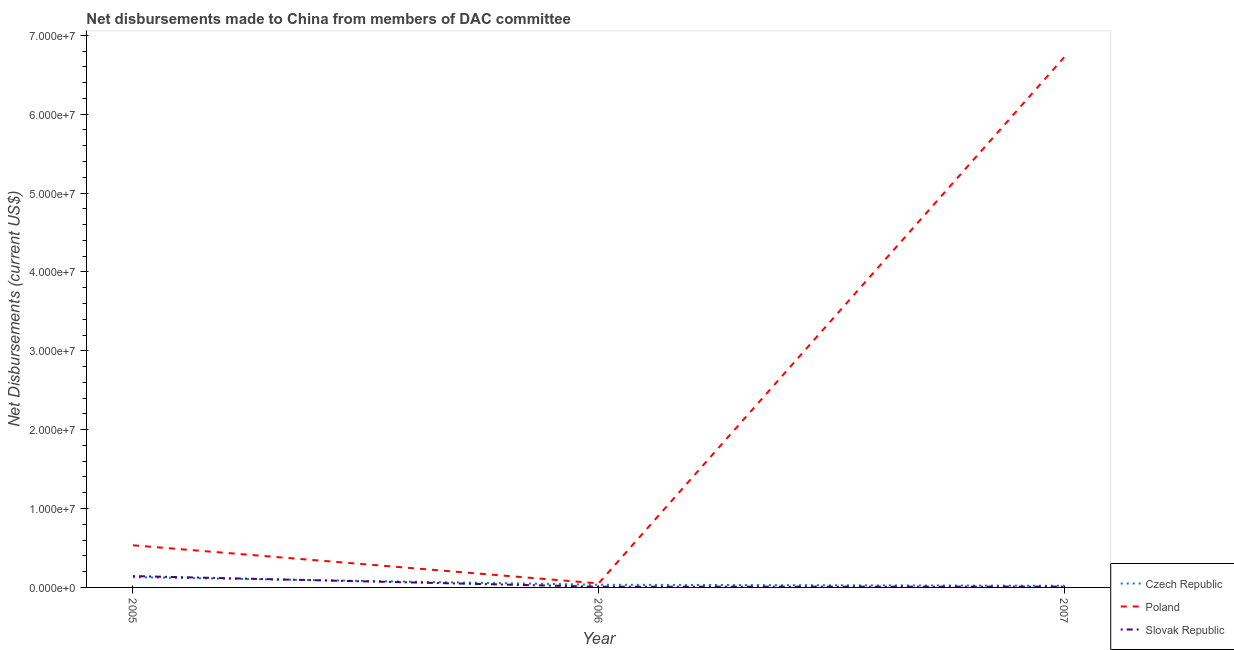How many different coloured lines are there?
Ensure brevity in your answer.  3. What is the net disbursements made by slovak republic in 2007?
Your answer should be very brief. 1.00e+05. Across all years, what is the maximum net disbursements made by poland?
Your answer should be compact. 6.72e+07. Across all years, what is the minimum net disbursements made by poland?
Keep it short and to the point. 5.10e+05. In which year was the net disbursements made by poland minimum?
Give a very brief answer. 2006. What is the total net disbursements made by czech republic in the graph?
Your response must be concise. 1.85e+06. What is the difference between the net disbursements made by slovak republic in 2005 and that in 2007?
Provide a short and direct response. 1.34e+06. What is the difference between the net disbursements made by poland in 2007 and the net disbursements made by czech republic in 2005?
Your answer should be very brief. 6.59e+07. What is the average net disbursements made by poland per year?
Provide a succinct answer. 2.44e+07. In the year 2005, what is the difference between the net disbursements made by slovak republic and net disbursements made by poland?
Provide a succinct answer. -3.90e+06. In how many years, is the net disbursements made by czech republic greater than 32000000 US$?
Your answer should be compact. 0. What is the ratio of the net disbursements made by czech republic in 2005 to that in 2007?
Offer a very short reply. 6.19. Is the net disbursements made by czech republic in 2006 less than that in 2007?
Your answer should be very brief. No. Is the difference between the net disbursements made by poland in 2005 and 2006 greater than the difference between the net disbursements made by czech republic in 2005 and 2006?
Provide a succinct answer. Yes. What is the difference between the highest and the second highest net disbursements made by czech republic?
Ensure brevity in your answer.  9.60e+05. What is the difference between the highest and the lowest net disbursements made by poland?
Keep it short and to the point. 6.67e+07. In how many years, is the net disbursements made by poland greater than the average net disbursements made by poland taken over all years?
Give a very brief answer. 1. Is it the case that in every year, the sum of the net disbursements made by czech republic and net disbursements made by poland is greater than the net disbursements made by slovak republic?
Offer a terse response. Yes. Does the net disbursements made by poland monotonically increase over the years?
Make the answer very short. No. What is the difference between two consecutive major ticks on the Y-axis?
Offer a very short reply. 1.00e+07. Are the values on the major ticks of Y-axis written in scientific E-notation?
Your response must be concise. Yes. Where does the legend appear in the graph?
Make the answer very short. Bottom right. How many legend labels are there?
Your response must be concise. 3. What is the title of the graph?
Keep it short and to the point. Net disbursements made to China from members of DAC committee. What is the label or title of the X-axis?
Make the answer very short. Year. What is the label or title of the Y-axis?
Make the answer very short. Net Disbursements (current US$). What is the Net Disbursements (current US$) in Czech Republic in 2005?
Provide a short and direct response. 1.30e+06. What is the Net Disbursements (current US$) in Poland in 2005?
Give a very brief answer. 5.34e+06. What is the Net Disbursements (current US$) of Slovak Republic in 2005?
Make the answer very short. 1.44e+06. What is the Net Disbursements (current US$) of Poland in 2006?
Offer a terse response. 5.10e+05. What is the Net Disbursements (current US$) in Slovak Republic in 2006?
Offer a terse response. 9.00e+04. What is the Net Disbursements (current US$) in Poland in 2007?
Offer a terse response. 6.72e+07. Across all years, what is the maximum Net Disbursements (current US$) in Czech Republic?
Keep it short and to the point. 1.30e+06. Across all years, what is the maximum Net Disbursements (current US$) of Poland?
Provide a short and direct response. 6.72e+07. Across all years, what is the maximum Net Disbursements (current US$) in Slovak Republic?
Your answer should be compact. 1.44e+06. Across all years, what is the minimum Net Disbursements (current US$) in Poland?
Give a very brief answer. 5.10e+05. Across all years, what is the minimum Net Disbursements (current US$) in Slovak Republic?
Provide a succinct answer. 9.00e+04. What is the total Net Disbursements (current US$) of Czech Republic in the graph?
Ensure brevity in your answer.  1.85e+06. What is the total Net Disbursements (current US$) in Poland in the graph?
Offer a terse response. 7.31e+07. What is the total Net Disbursements (current US$) of Slovak Republic in the graph?
Your answer should be compact. 1.63e+06. What is the difference between the Net Disbursements (current US$) of Czech Republic in 2005 and that in 2006?
Offer a terse response. 9.60e+05. What is the difference between the Net Disbursements (current US$) of Poland in 2005 and that in 2006?
Keep it short and to the point. 4.83e+06. What is the difference between the Net Disbursements (current US$) of Slovak Republic in 2005 and that in 2006?
Ensure brevity in your answer.  1.35e+06. What is the difference between the Net Disbursements (current US$) of Czech Republic in 2005 and that in 2007?
Provide a succinct answer. 1.09e+06. What is the difference between the Net Disbursements (current US$) in Poland in 2005 and that in 2007?
Ensure brevity in your answer.  -6.19e+07. What is the difference between the Net Disbursements (current US$) of Slovak Republic in 2005 and that in 2007?
Keep it short and to the point. 1.34e+06. What is the difference between the Net Disbursements (current US$) in Poland in 2006 and that in 2007?
Your answer should be very brief. -6.67e+07. What is the difference between the Net Disbursements (current US$) in Czech Republic in 2005 and the Net Disbursements (current US$) in Poland in 2006?
Provide a short and direct response. 7.90e+05. What is the difference between the Net Disbursements (current US$) in Czech Republic in 2005 and the Net Disbursements (current US$) in Slovak Republic in 2006?
Offer a terse response. 1.21e+06. What is the difference between the Net Disbursements (current US$) of Poland in 2005 and the Net Disbursements (current US$) of Slovak Republic in 2006?
Your answer should be very brief. 5.25e+06. What is the difference between the Net Disbursements (current US$) in Czech Republic in 2005 and the Net Disbursements (current US$) in Poland in 2007?
Make the answer very short. -6.59e+07. What is the difference between the Net Disbursements (current US$) of Czech Republic in 2005 and the Net Disbursements (current US$) of Slovak Republic in 2007?
Keep it short and to the point. 1.20e+06. What is the difference between the Net Disbursements (current US$) in Poland in 2005 and the Net Disbursements (current US$) in Slovak Republic in 2007?
Provide a short and direct response. 5.24e+06. What is the difference between the Net Disbursements (current US$) of Czech Republic in 2006 and the Net Disbursements (current US$) of Poland in 2007?
Give a very brief answer. -6.69e+07. What is the average Net Disbursements (current US$) in Czech Republic per year?
Provide a short and direct response. 6.17e+05. What is the average Net Disbursements (current US$) of Poland per year?
Your answer should be compact. 2.44e+07. What is the average Net Disbursements (current US$) in Slovak Republic per year?
Provide a short and direct response. 5.43e+05. In the year 2005, what is the difference between the Net Disbursements (current US$) in Czech Republic and Net Disbursements (current US$) in Poland?
Your answer should be compact. -4.04e+06. In the year 2005, what is the difference between the Net Disbursements (current US$) of Czech Republic and Net Disbursements (current US$) of Slovak Republic?
Your answer should be compact. -1.40e+05. In the year 2005, what is the difference between the Net Disbursements (current US$) of Poland and Net Disbursements (current US$) of Slovak Republic?
Give a very brief answer. 3.90e+06. In the year 2006, what is the difference between the Net Disbursements (current US$) in Poland and Net Disbursements (current US$) in Slovak Republic?
Offer a very short reply. 4.20e+05. In the year 2007, what is the difference between the Net Disbursements (current US$) in Czech Republic and Net Disbursements (current US$) in Poland?
Offer a very short reply. -6.70e+07. In the year 2007, what is the difference between the Net Disbursements (current US$) of Poland and Net Disbursements (current US$) of Slovak Republic?
Your answer should be compact. 6.71e+07. What is the ratio of the Net Disbursements (current US$) of Czech Republic in 2005 to that in 2006?
Provide a short and direct response. 3.82. What is the ratio of the Net Disbursements (current US$) of Poland in 2005 to that in 2006?
Give a very brief answer. 10.47. What is the ratio of the Net Disbursements (current US$) of Slovak Republic in 2005 to that in 2006?
Offer a very short reply. 16. What is the ratio of the Net Disbursements (current US$) of Czech Republic in 2005 to that in 2007?
Provide a short and direct response. 6.19. What is the ratio of the Net Disbursements (current US$) of Poland in 2005 to that in 2007?
Provide a succinct answer. 0.08. What is the ratio of the Net Disbursements (current US$) in Czech Republic in 2006 to that in 2007?
Make the answer very short. 1.62. What is the ratio of the Net Disbursements (current US$) of Poland in 2006 to that in 2007?
Your answer should be very brief. 0.01. What is the ratio of the Net Disbursements (current US$) of Slovak Republic in 2006 to that in 2007?
Provide a short and direct response. 0.9. What is the difference between the highest and the second highest Net Disbursements (current US$) of Czech Republic?
Make the answer very short. 9.60e+05. What is the difference between the highest and the second highest Net Disbursements (current US$) in Poland?
Ensure brevity in your answer.  6.19e+07. What is the difference between the highest and the second highest Net Disbursements (current US$) of Slovak Republic?
Provide a succinct answer. 1.34e+06. What is the difference between the highest and the lowest Net Disbursements (current US$) in Czech Republic?
Offer a terse response. 1.09e+06. What is the difference between the highest and the lowest Net Disbursements (current US$) in Poland?
Offer a terse response. 6.67e+07. What is the difference between the highest and the lowest Net Disbursements (current US$) in Slovak Republic?
Offer a terse response. 1.35e+06. 